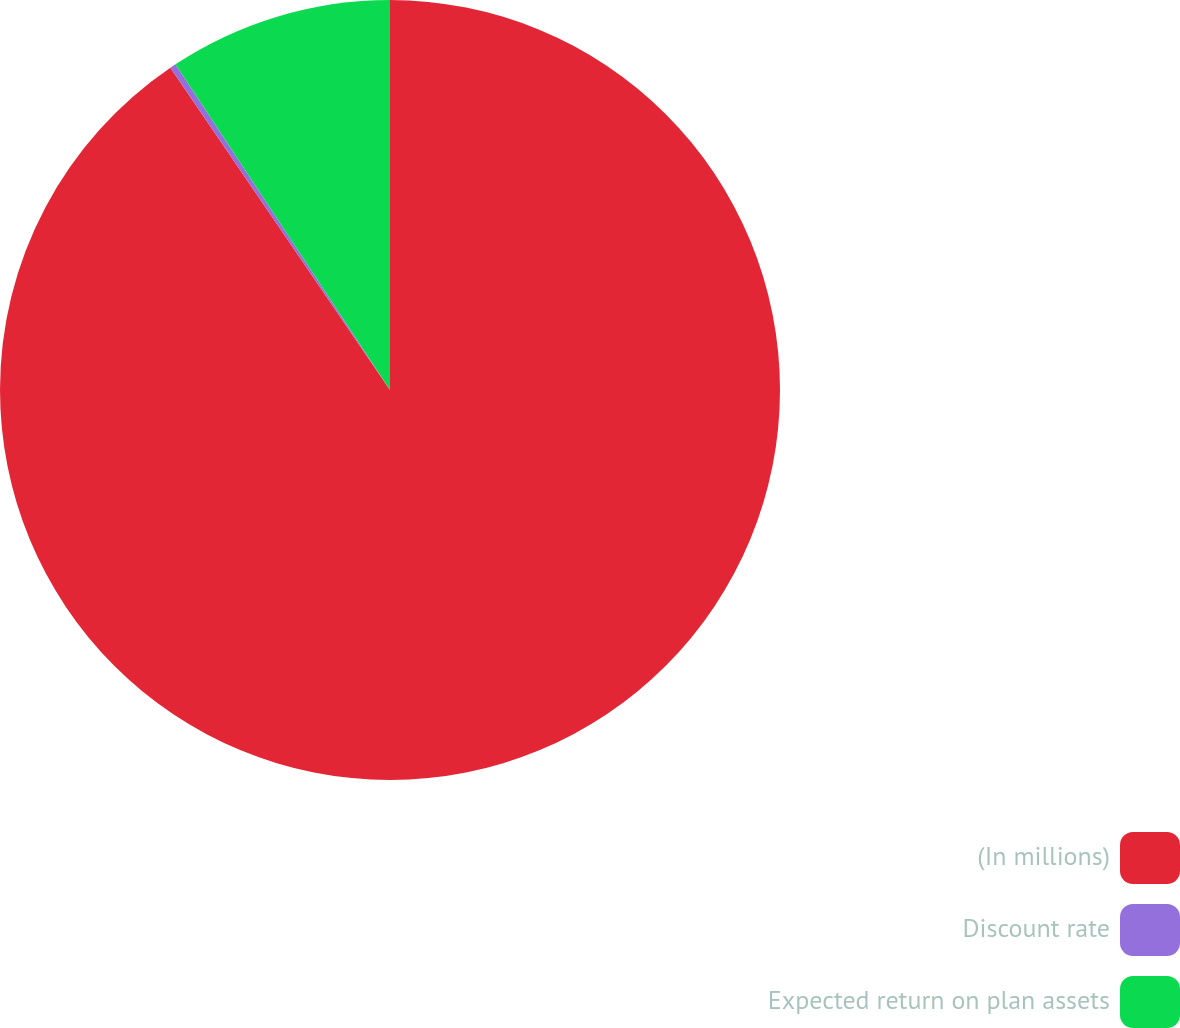Convert chart. <chart><loc_0><loc_0><loc_500><loc_500><pie_chart><fcel>(In millions)<fcel>Discount rate<fcel>Expected return on plan assets<nl><fcel>90.47%<fcel>0.25%<fcel>9.27%<nl></chart> 